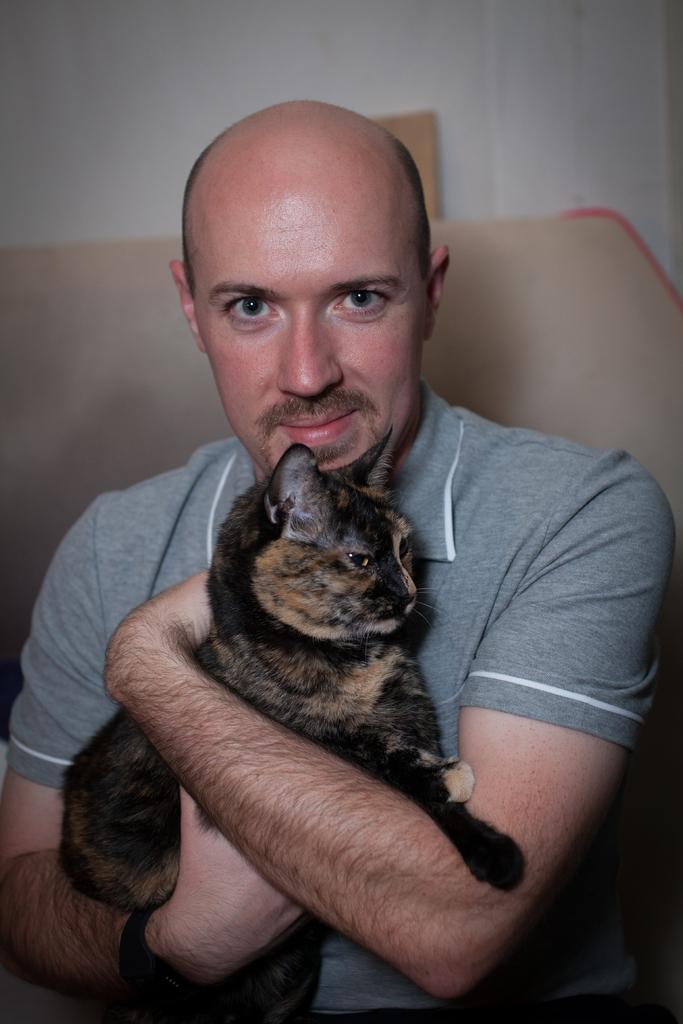Who is present in the image? There is a man in the image. What is the man holding in the image? The man is holding a cat. Where is the man sitting in the image? The man is sitting on a sofa. What type of park can be seen in the background of the image? There is no park visible in the image; it features a man holding a cat while sitting on a sofa. 